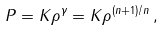Convert formula to latex. <formula><loc_0><loc_0><loc_500><loc_500>P = K \rho ^ { \gamma } = K \rho ^ { ( n + 1 ) / n } \, ,</formula> 